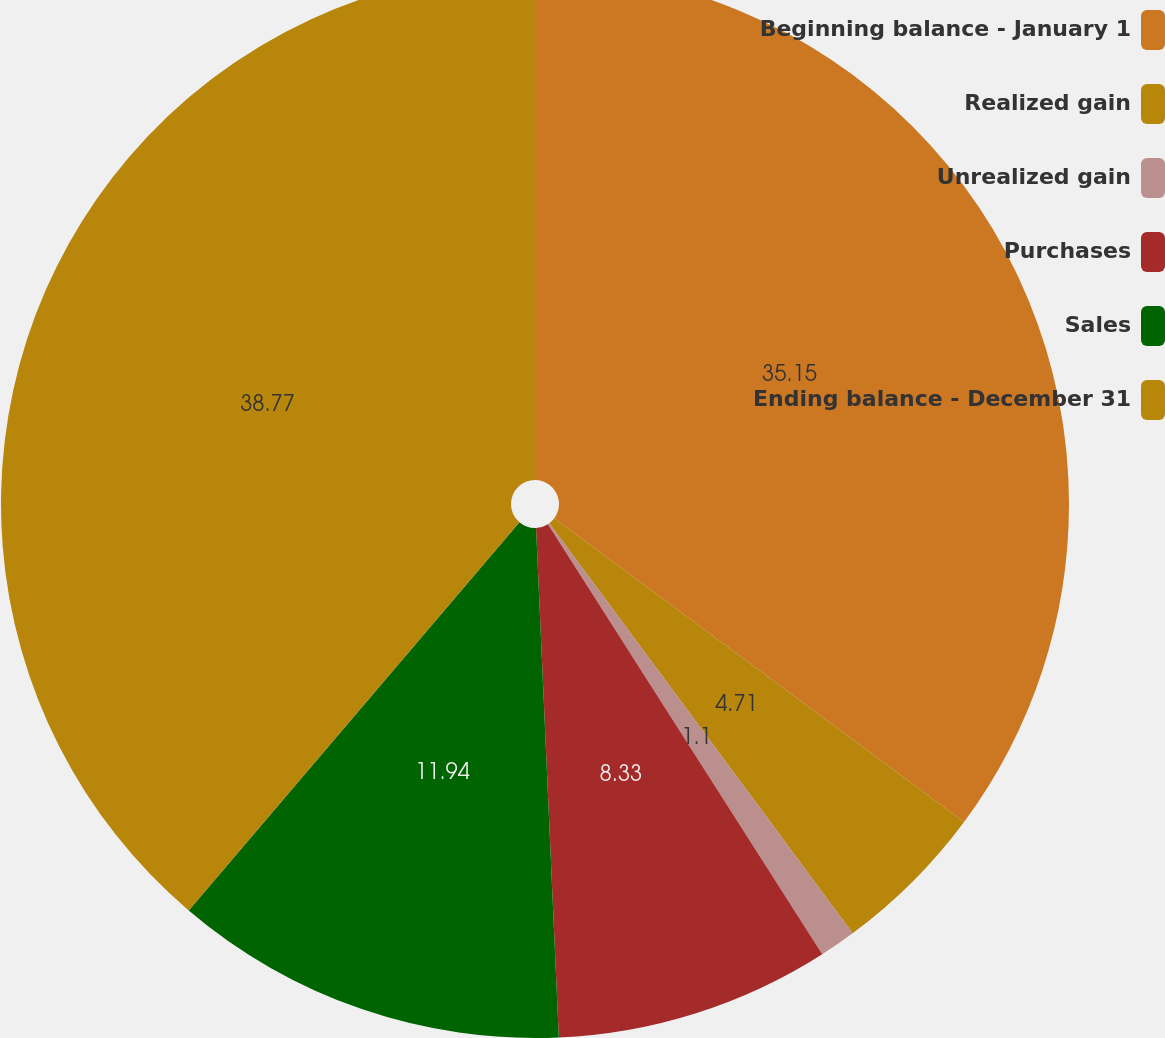Convert chart to OTSL. <chart><loc_0><loc_0><loc_500><loc_500><pie_chart><fcel>Beginning balance - January 1<fcel>Realized gain<fcel>Unrealized gain<fcel>Purchases<fcel>Sales<fcel>Ending balance - December 31<nl><fcel>35.15%<fcel>4.71%<fcel>1.1%<fcel>8.33%<fcel>11.94%<fcel>38.77%<nl></chart> 